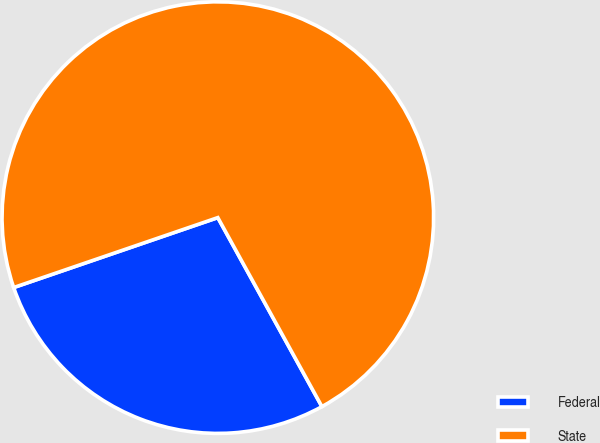<chart> <loc_0><loc_0><loc_500><loc_500><pie_chart><fcel>Federal<fcel>State<nl><fcel>27.76%<fcel>72.24%<nl></chart> 